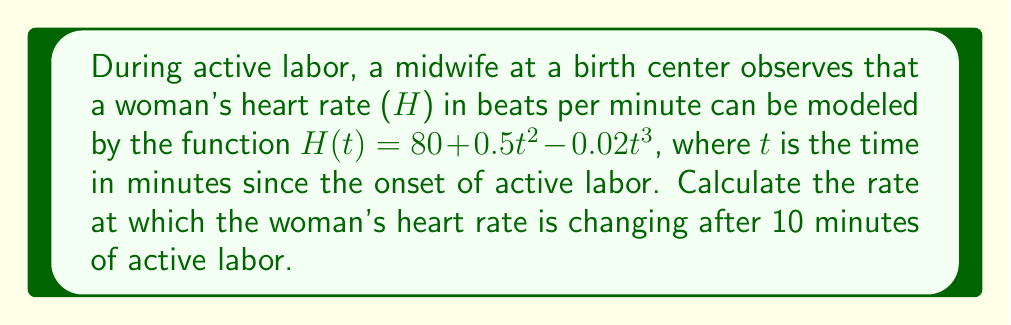Can you answer this question? To find the rate at which the woman's heart rate is changing, we need to calculate the derivative of the heart rate function H(t) and evaluate it at t = 10 minutes.

Step 1: Find the derivative of H(t)
$$H(t) = 80 + 0.5t^2 - 0.02t^3$$
$$H'(t) = 0 + 0.5 \cdot 2t - 0.02 \cdot 3t^2$$
$$H'(t) = t - 0.06t^2$$

Step 2: Evaluate H'(t) at t = 10
$$H'(10) = 10 - 0.06(10)^2$$
$$H'(10) = 10 - 0.06(100)$$
$$H'(10) = 10 - 6$$
$$H'(10) = 4$$

The rate of change is 4 beats per minute per minute, or 4 bpm/min.
Answer: 4 bpm/min 